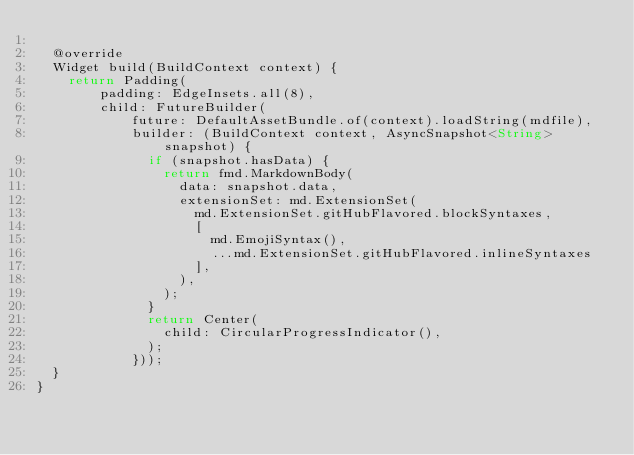<code> <loc_0><loc_0><loc_500><loc_500><_Dart_>
  @override
  Widget build(BuildContext context) {
    return Padding(
        padding: EdgeInsets.all(8),
        child: FutureBuilder(
            future: DefaultAssetBundle.of(context).loadString(mdfile),
            builder: (BuildContext context, AsyncSnapshot<String> snapshot) {
              if (snapshot.hasData) {
                return fmd.MarkdownBody(
                  data: snapshot.data,
                  extensionSet: md.ExtensionSet(
                    md.ExtensionSet.gitHubFlavored.blockSyntaxes,
                    [
                      md.EmojiSyntax(),
                      ...md.ExtensionSet.gitHubFlavored.inlineSyntaxes
                    ],
                  ),
                );
              }
              return Center(
                child: CircularProgressIndicator(),
              );
            }));
  }
}
</code> 